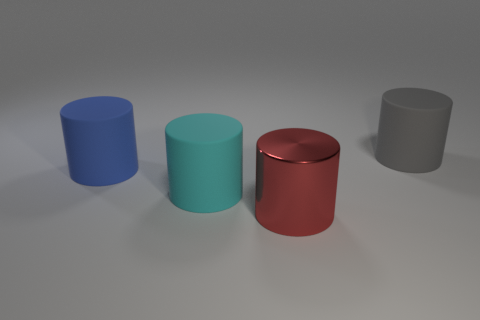Add 2 tiny cyan rubber cylinders. How many objects exist? 6 Subtract all big matte cylinders. How many cylinders are left? 1 Subtract all red cylinders. Subtract all cyan blocks. How many cylinders are left? 3 Subtract all red shiny cylinders. Subtract all red cylinders. How many objects are left? 2 Add 4 cyan cylinders. How many cyan cylinders are left? 5 Add 3 blue matte things. How many blue matte things exist? 4 Subtract 0 purple spheres. How many objects are left? 4 